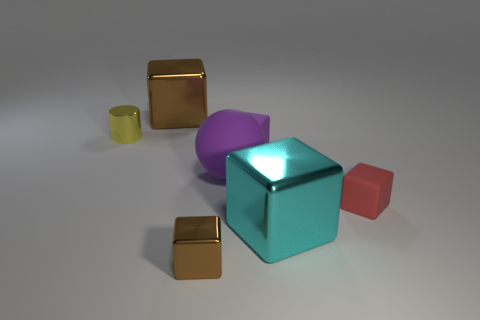What materials do the objects in the image look like they're made of? The objects in the image seem to have a variety of textures suggesting different materials. The large blue cube and the small gold cubes have a reflective, metallic appearance, while the pink and purple items have a matte finish, perhaps resembling plastic or painted surfaces. Do the objects cast shadows and what does that tell us about the lighting in the scene? Each object casts a soft shadow, indicating diffuse lighting in the scene, possibly from a source above and off to one side, giving a sense of depth and dimension to the objects. 